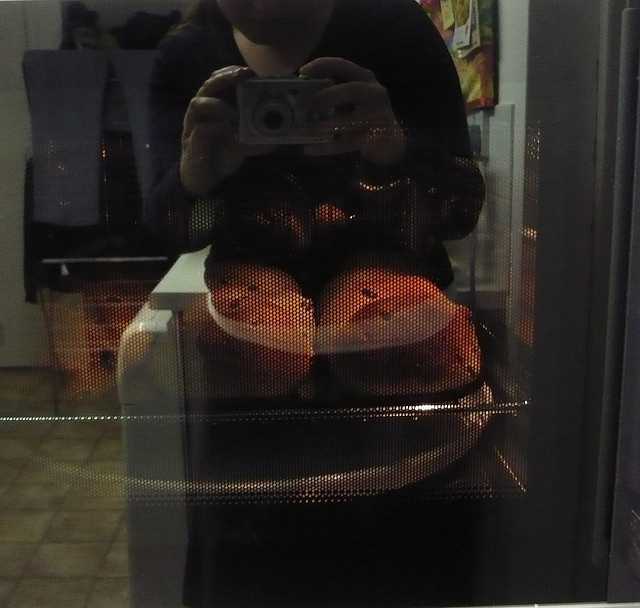Describe the objects in this image and their specific colors. I can see people in lightgray, black, maroon, and brown tones in this image. 